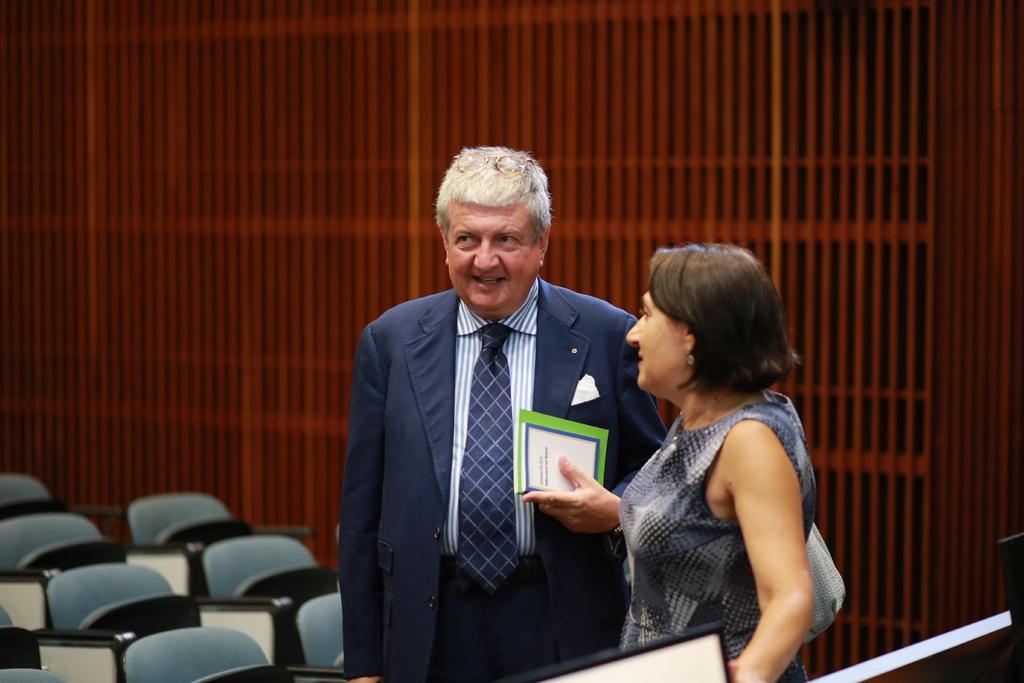Describe this image in one or two sentences. In this image we can see a man and a woman. The man is wearing a shirt, blue coat, tie and holding books in his hand. The woman is wearing grey color dress and carrying bag. There are chairs in the left bottom of the image. We can see the wall in the background and some objects at the bottom of the image. 